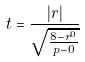Convert formula to latex. <formula><loc_0><loc_0><loc_500><loc_500>t = \frac { | r | } { \sqrt { \frac { 8 - r ^ { 0 } } { p - 0 } } }</formula> 